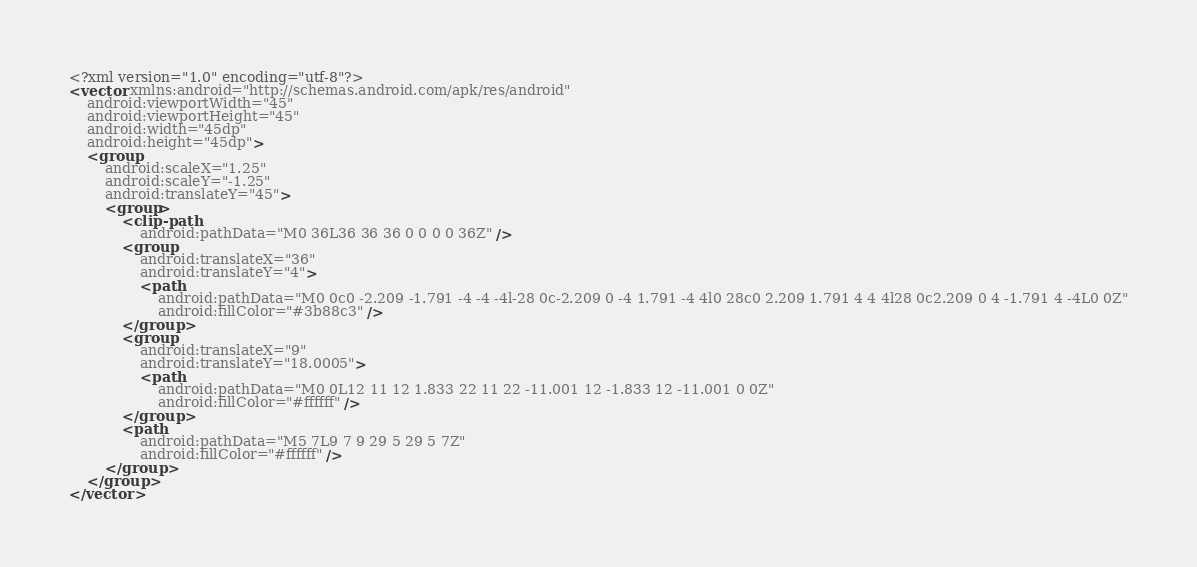Convert code to text. <code><loc_0><loc_0><loc_500><loc_500><_XML_><?xml version="1.0" encoding="utf-8"?>
<vector xmlns:android="http://schemas.android.com/apk/res/android"
    android:viewportWidth="45"
    android:viewportHeight="45"
    android:width="45dp"
    android:height="45dp">
    <group
        android:scaleX="1.25"
        android:scaleY="-1.25"
        android:translateY="45">
        <group>
            <clip-path
                android:pathData="M0 36L36 36 36 0 0 0 0 36Z" />
            <group
                android:translateX="36"
                android:translateY="4">
                <path
                    android:pathData="M0 0c0 -2.209 -1.791 -4 -4 -4l-28 0c-2.209 0 -4 1.791 -4 4l0 28c0 2.209 1.791 4 4 4l28 0c2.209 0 4 -1.791 4 -4L0 0Z"
                    android:fillColor="#3b88c3" />
            </group>
            <group
                android:translateX="9"
                android:translateY="18.0005">
                <path
                    android:pathData="M0 0L12 11 12 1.833 22 11 22 -11.001 12 -1.833 12 -11.001 0 0Z"
                    android:fillColor="#ffffff" />
            </group>
            <path
                android:pathData="M5 7L9 7 9 29 5 29 5 7Z"
                android:fillColor="#ffffff" />
        </group>
    </group>
</vector></code> 